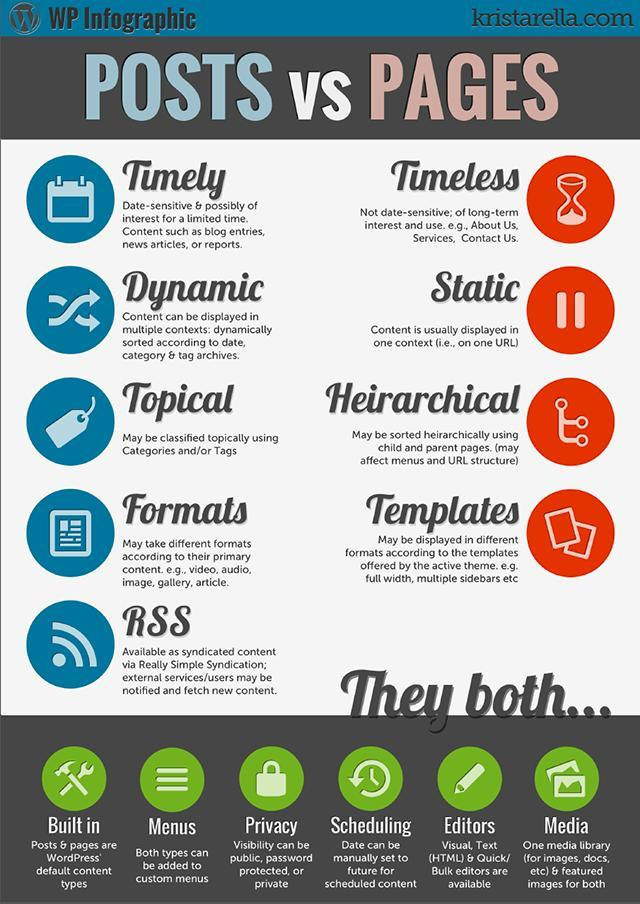What does RSS stand for?
Answer the question with a short phrase. Really Simple Syndication What are the options for visibility for both pages and posts? public,password protected,private 